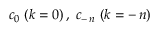Convert formula to latex. <formula><loc_0><loc_0><loc_500><loc_500>\, c _ { 0 } \, ( k = 0 ) \, , \, c _ { - \, n } \, ( k = - \, n ) \,</formula> 